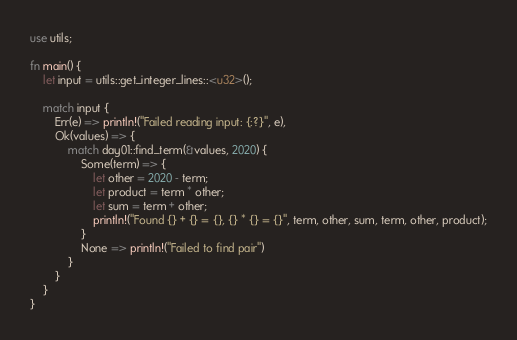<code> <loc_0><loc_0><loc_500><loc_500><_Rust_>use utils;

fn main() {
    let input = utils::get_integer_lines::<u32>();

    match input {
        Err(e) => println!("Failed reading input: {:?}", e),
        Ok(values) => {
            match day01::find_term(&values, 2020) {
                Some(term) => {
                    let other = 2020 - term;
                    let product = term * other;
                    let sum = term + other;
                    println!("Found {} + {} = {}, {} * {} = {}", term, other, sum, term, other, product);
                }
                None => println!("Failed to find pair")
            }
        }
    }
}
</code> 